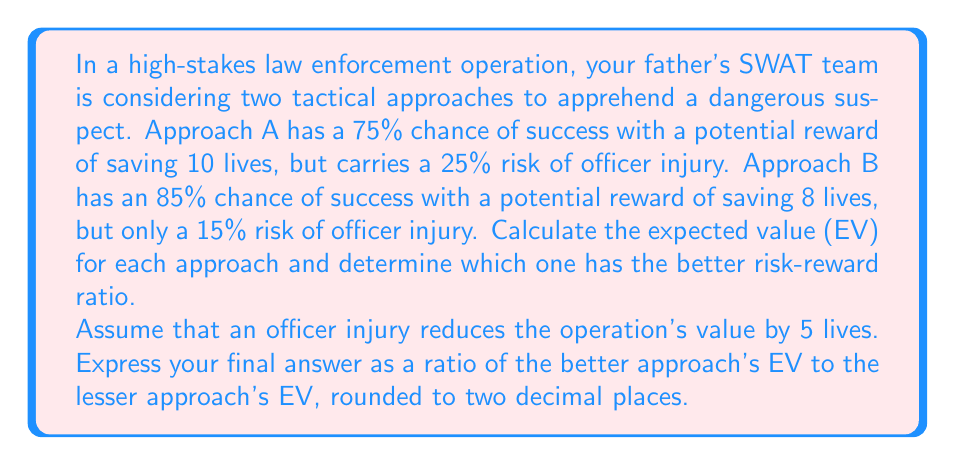Give your solution to this math problem. Let's break this problem down step-by-step:

1. Calculate the Expected Value (EV) for Approach A:
   $EV_A = (0.75 \times 10) + (0.25 \times (-5)) = 7.5 - 1.25 = 6.25$

2. Calculate the Expected Value (EV) for Approach B:
   $EV_B = (0.85 \times 8) + (0.15 \times (-5)) = 6.8 - 0.75 = 6.05$

3. Compare the two EVs:
   Approach A has a higher EV (6.25) compared to Approach B (6.05)

4. Calculate the ratio of the better approach's EV to the lesser approach's EV:
   $\text{Ratio} = \frac{EV_A}{EV_B} = \frac{6.25}{6.05} \approx 1.03306$

5. Round the ratio to two decimal places:
   $1.03$

This result indicates that Approach A has a slightly better risk-reward ratio, being about 1.03 times better than Approach B.
Answer: 1.03 